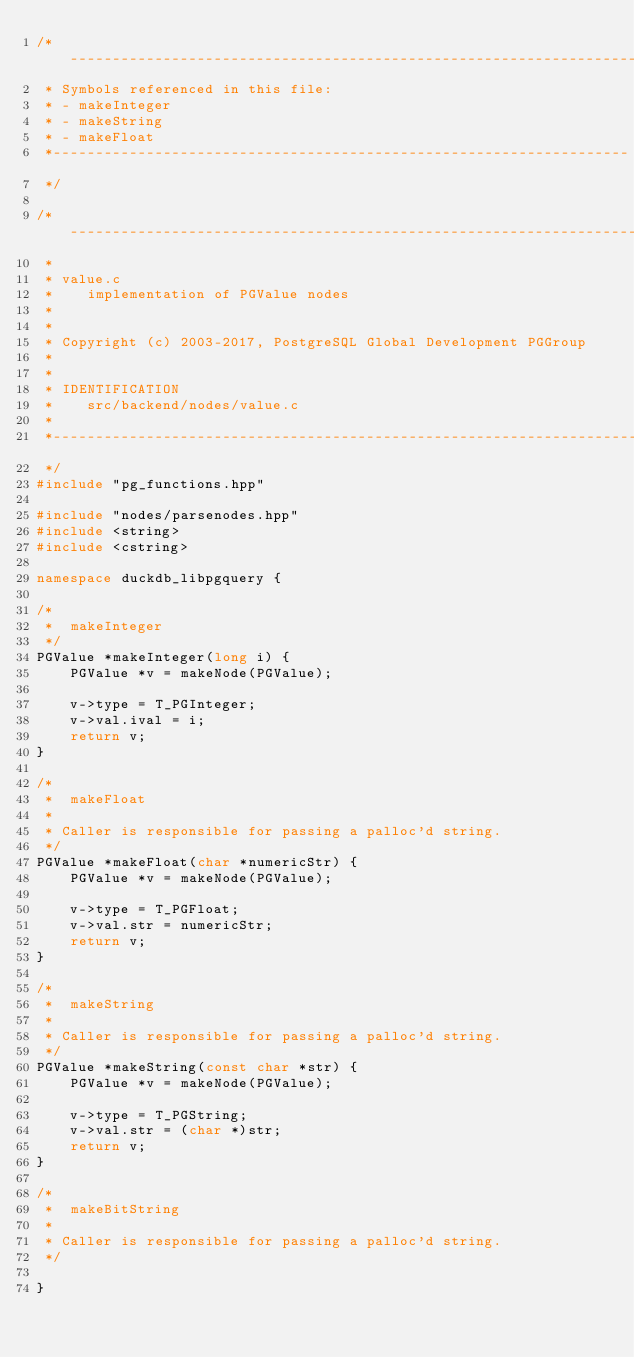Convert code to text. <code><loc_0><loc_0><loc_500><loc_500><_C++_>/*--------------------------------------------------------------------
 * Symbols referenced in this file:
 * - makeInteger
 * - makeString
 * - makeFloat
 *--------------------------------------------------------------------
 */

/*-------------------------------------------------------------------------
 *
 * value.c
 *	  implementation of PGValue nodes
 *
 *
 * Copyright (c) 2003-2017, PostgreSQL Global Development PGGroup
 *
 *
 * IDENTIFICATION
 *	  src/backend/nodes/value.c
 *
 *-------------------------------------------------------------------------
 */
#include "pg_functions.hpp"

#include "nodes/parsenodes.hpp"
#include <string>
#include <cstring>

namespace duckdb_libpgquery {

/*
 *	makeInteger
 */
PGValue *makeInteger(long i) {
	PGValue *v = makeNode(PGValue);

	v->type = T_PGInteger;
	v->val.ival = i;
	return v;
}

/*
 *	makeFloat
 *
 * Caller is responsible for passing a palloc'd string.
 */
PGValue *makeFloat(char *numericStr) {
	PGValue *v = makeNode(PGValue);

	v->type = T_PGFloat;
	v->val.str = numericStr;
	return v;
}

/*
 *	makeString
 *
 * Caller is responsible for passing a palloc'd string.
 */
PGValue *makeString(const char *str) {
	PGValue *v = makeNode(PGValue);

	v->type = T_PGString;
	v->val.str = (char *)str;
	return v;
}

/*
 *	makeBitString
 *
 * Caller is responsible for passing a palloc'd string.
 */

}</code> 